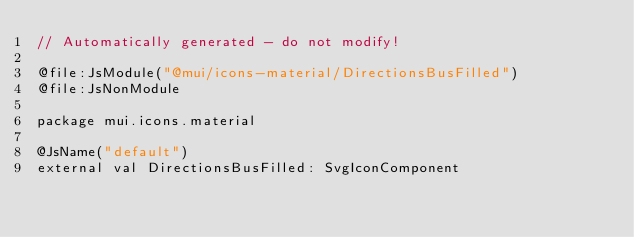Convert code to text. <code><loc_0><loc_0><loc_500><loc_500><_Kotlin_>// Automatically generated - do not modify!

@file:JsModule("@mui/icons-material/DirectionsBusFilled")
@file:JsNonModule

package mui.icons.material

@JsName("default")
external val DirectionsBusFilled: SvgIconComponent
</code> 